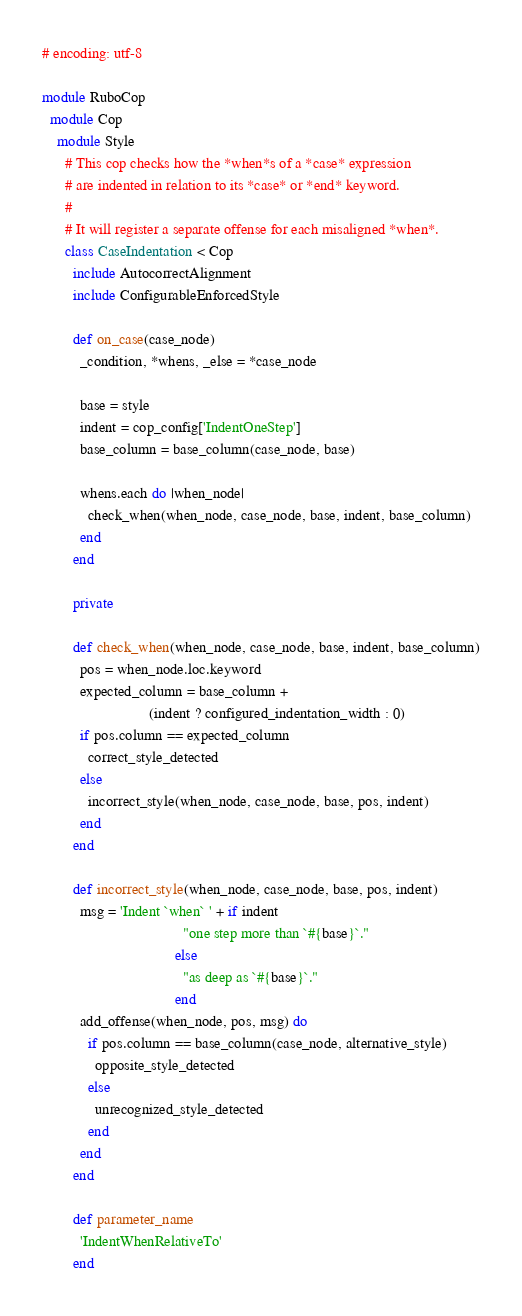Convert code to text. <code><loc_0><loc_0><loc_500><loc_500><_Ruby_># encoding: utf-8

module RuboCop
  module Cop
    module Style
      # This cop checks how the *when*s of a *case* expression
      # are indented in relation to its *case* or *end* keyword.
      #
      # It will register a separate offense for each misaligned *when*.
      class CaseIndentation < Cop
        include AutocorrectAlignment
        include ConfigurableEnforcedStyle

        def on_case(case_node)
          _condition, *whens, _else = *case_node

          base = style
          indent = cop_config['IndentOneStep']
          base_column = base_column(case_node, base)

          whens.each do |when_node|
            check_when(when_node, case_node, base, indent, base_column)
          end
        end

        private

        def check_when(when_node, case_node, base, indent, base_column)
          pos = when_node.loc.keyword
          expected_column = base_column +
                            (indent ? configured_indentation_width : 0)
          if pos.column == expected_column
            correct_style_detected
          else
            incorrect_style(when_node, case_node, base, pos, indent)
          end
        end

        def incorrect_style(when_node, case_node, base, pos, indent)
          msg = 'Indent `when` ' + if indent
                                     "one step more than `#{base}`."
                                   else
                                     "as deep as `#{base}`."
                                   end
          add_offense(when_node, pos, msg) do
            if pos.column == base_column(case_node, alternative_style)
              opposite_style_detected
            else
              unrecognized_style_detected
            end
          end
        end

        def parameter_name
          'IndentWhenRelativeTo'
        end
</code> 